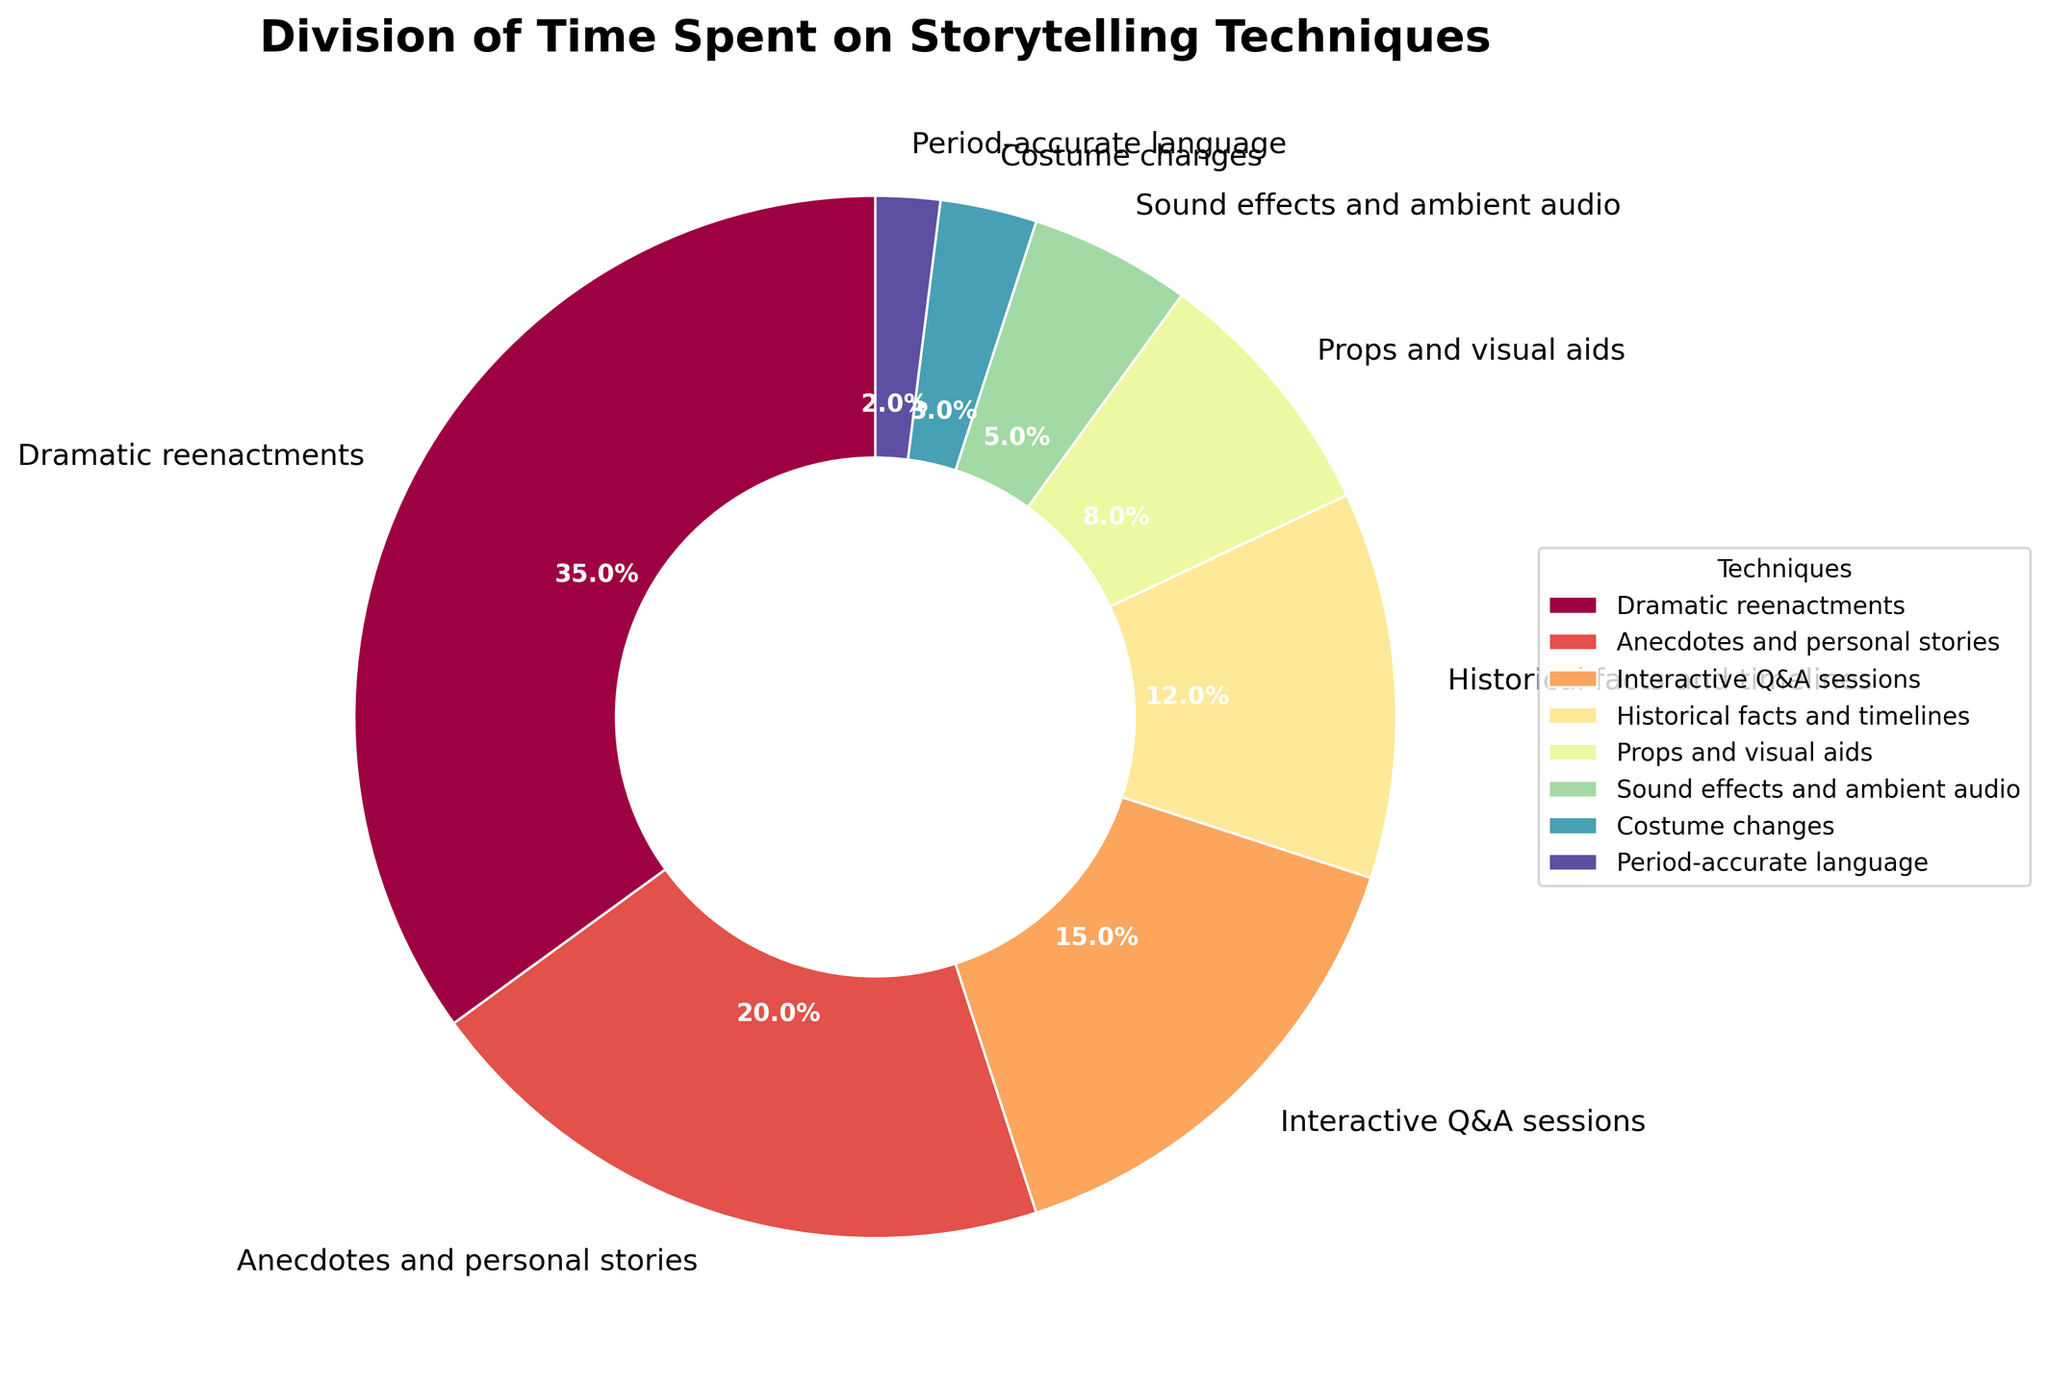Which storytelling technique uses the most time? The section with the largest slice represents the technique using the most time, which is labeled "Dramatic reenactments" with 35%.
Answer: Dramatic reenactments Compare the time spent on Anecdotes and personal stories with Historical facts and timelines. Which takes more time and by how much? Anecdotes and personal stories have 20%, while Historical facts and timelines have 12%. The difference is 20% - 12%.
Answer: Anecdotes and personal stories take 8% more time What is the total percentage of time spent on Props and visual aids, Sound effects and ambient audio, and Costume changes? Props and visual aids take 8%, Sound effects and ambient audio take 5%, and Costume changes take 3%. Adding these values gives 8% + 5% + 3%.
Answer: 16% Which techniques share a similar color shading in the pie chart? Props and visual aids share a similar color shading with Historical facts and timelines, as they are adjacent sections with very close hues in the color gradient.
Answer: Props and visual aids and Historical facts and timelines What is the least used technique in terms of time, and what percentage of the time does it consume? The smallest slice in the pie chart represents the least used technique, which is "Period-accurate language" with 2%.
Answer: Period-accurate language How much more time is spent on Interactive Q&A sessions compared to Costume changes? Interactive Q&A sessions account for 15%, while Costume changes account for 3%. The difference is 15% - 3%.
Answer: 12% Describe the visual representation of the section for Sound effects and ambient audio. The section is a small slice with a medium shade, located between Props and visual aids and Costume changes in the lower part of the pie chart, labeled as 5%.
Answer: A small, medium-shaded slice labeled 5% What is the combined percentage of time spent on techniques other than Dramatic reenactments and Anecdotes and personal stories? The total percentage of the chart is 100%. Subtract the time spent on Dramatic reenactments (35%) and Anecdotes and personal stories (20%) from the total. 100% - 35% - 20%.
Answer: 45% How does the time spent on Historical facts and timelines compare to that of Interactive Q&A sessions? Historical facts and timelines account for 12%, whereas Interactive Q&A sessions account for 15%. Interactive Q&A sessions take 3% more time.
Answer: Interactive Q&A sessions take 3% more time What portion of the pie chart is taken up by techniques that each individually consume less than 10% of the time? Techniques less than 10%: Props and visual aids (8%), Sound effects and ambient audio (5%), Costume changes (3%), Period-accurate language (2%). Add these percentages: 8% + 5% + 3% + 2%.
Answer: 18% 